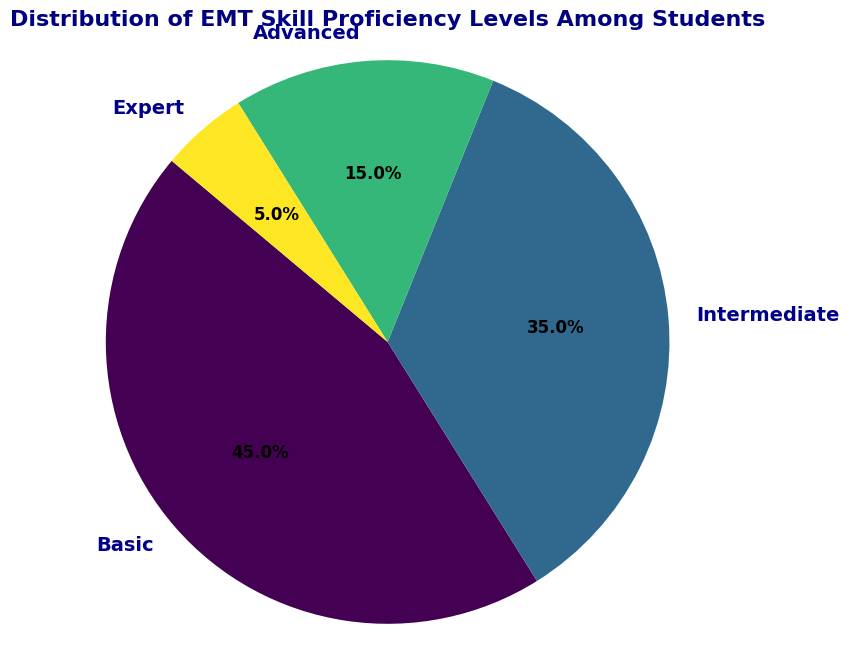What percentage of students are at the Basic proficiency level? The Basic segment of the pie chart shows its percentage value. According to the chart, the segment labeled Basic has a value of 45.0%.
Answer: 45.0% Which skill level has the smallest number of students? Analyzing the size of the pie chart segments, the smallest segment corresponds to the Expert skill level, as visually indicated by its small size and 5.0% label.
Answer: Expert How many more students are at the Basic level compared to the Advanced level? From the figure, Basic has 45 students, and Advanced has 15 students. The difference between these two levels is 45 - 15 = 30.
Answer: 30 What is the combined percentage of students at the Intermediate and Advanced levels? The pie chart shows Intermediate at 35.0% and Advanced at 15.0%. Adding these percentages gives 35.0% + 15.0% = 50.0%.
Answer: 50.0% Are there more students at the Intermediate level than at the Advanced and Expert levels combined? The Intermediate level has 35 students. The combined total of Advanced (15) and Expert (5) is 15 + 5 = 20 students. Since 35 > 20, there are indeed more Intermediate level students.
Answer: Yes What is the ratio of Basic level students to Expert level students? The pie chart indicates 45 Basic level students and 5 Expert level students. The ratio is 45:5, which simplifies to 9:1.
Answer: 9:1 Which two skill levels combined represent over half of the students? The Basic (45.0%) and Intermediate (35.0%) levels combine to 45.0% + 35.0% = 80.0%, which is over half of the students.
Answer: Basic and Intermediate If the percentages of students at the Basic and Intermediate levels were combined, what would that percentage value be? The chart shows Basic at 45.0% and Intermediate at 35.0%. Combined, their percentage is 45.0% + 35.0% = 80.0%.
Answer: 80.0% Which skill level is represented by the second largest segment in the pie chart? Based on the size of the segments, the second largest segment is labeled Intermediate, with 35.0% of the students.
Answer: Intermediate 